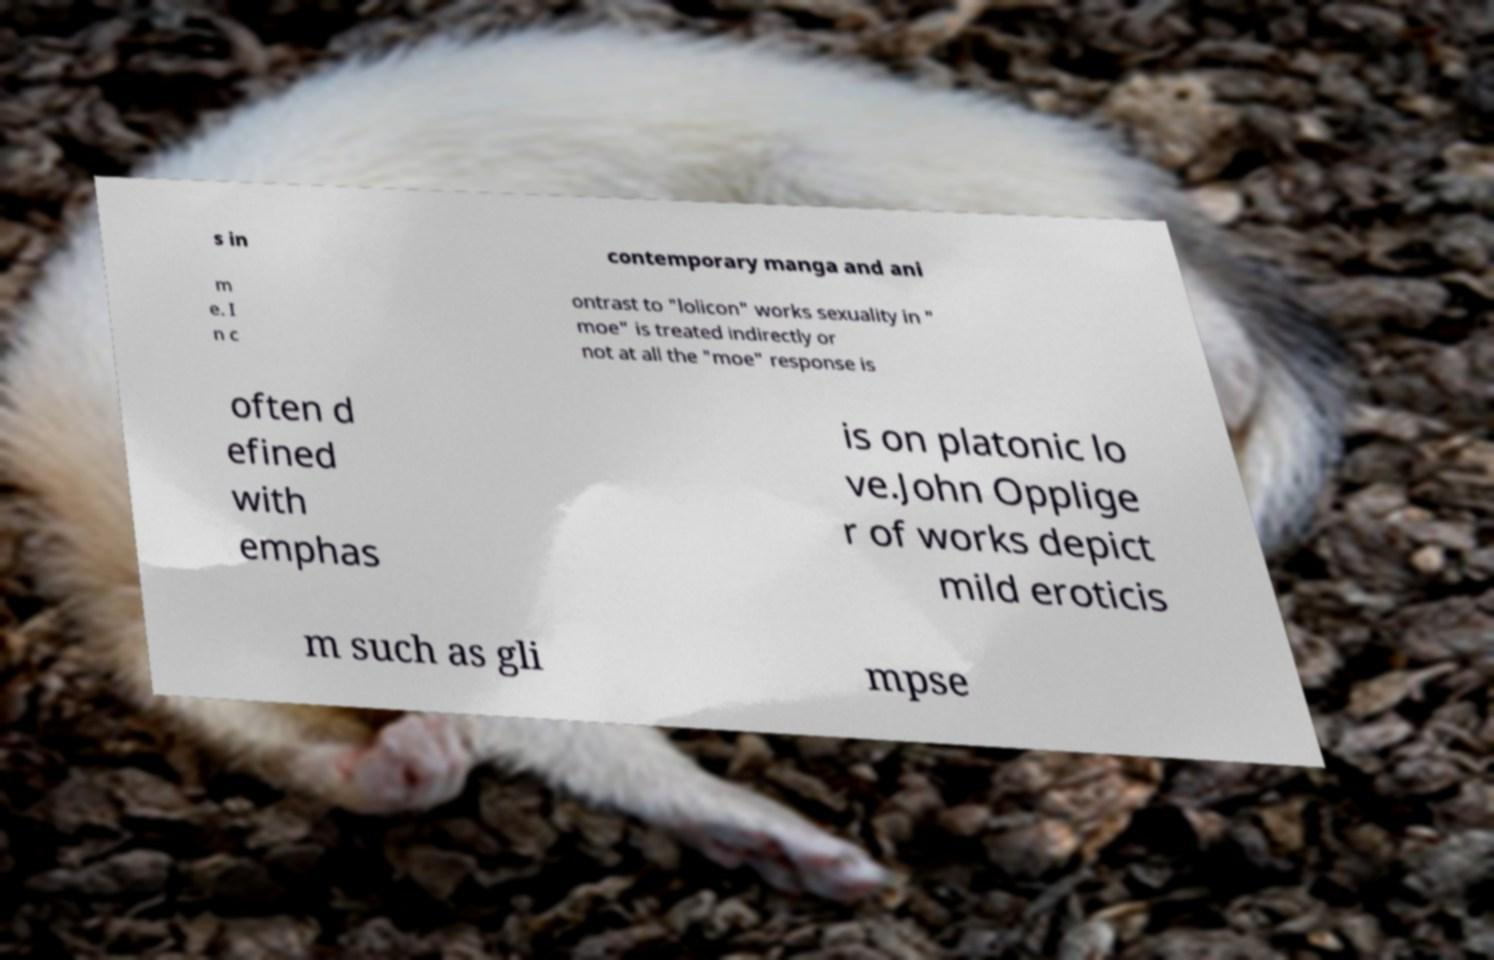Could you extract and type out the text from this image? s in contemporary manga and ani m e. I n c ontrast to "lolicon" works sexuality in " moe" is treated indirectly or not at all the "moe" response is often d efined with emphas is on platonic lo ve.John Opplige r of works depict mild eroticis m such as gli mpse 